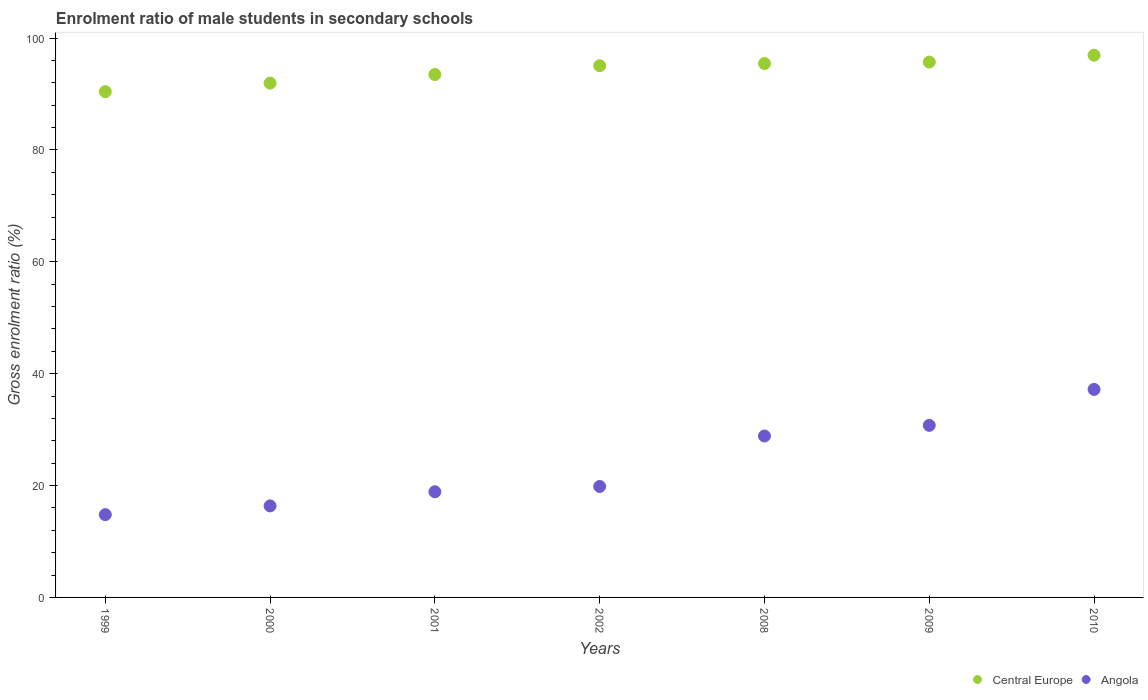How many different coloured dotlines are there?
Provide a succinct answer. 2. What is the enrolment ratio of male students in secondary schools in Angola in 2000?
Your response must be concise. 16.37. Across all years, what is the maximum enrolment ratio of male students in secondary schools in Angola?
Offer a very short reply. 37.19. Across all years, what is the minimum enrolment ratio of male students in secondary schools in Central Europe?
Provide a succinct answer. 90.43. In which year was the enrolment ratio of male students in secondary schools in Central Europe maximum?
Provide a succinct answer. 2010. In which year was the enrolment ratio of male students in secondary schools in Angola minimum?
Provide a short and direct response. 1999. What is the total enrolment ratio of male students in secondary schools in Central Europe in the graph?
Ensure brevity in your answer.  659.03. What is the difference between the enrolment ratio of male students in secondary schools in Angola in 2000 and that in 2008?
Your answer should be very brief. -12.5. What is the difference between the enrolment ratio of male students in secondary schools in Angola in 1999 and the enrolment ratio of male students in secondary schools in Central Europe in 2001?
Your response must be concise. -78.69. What is the average enrolment ratio of male students in secondary schools in Angola per year?
Your answer should be very brief. 23.82. In the year 2002, what is the difference between the enrolment ratio of male students in secondary schools in Central Europe and enrolment ratio of male students in secondary schools in Angola?
Keep it short and to the point. 75.22. What is the ratio of the enrolment ratio of male students in secondary schools in Angola in 2008 to that in 2010?
Your response must be concise. 0.78. Is the enrolment ratio of male students in secondary schools in Central Europe in 2000 less than that in 2001?
Your answer should be compact. Yes. What is the difference between the highest and the second highest enrolment ratio of male students in secondary schools in Angola?
Offer a very short reply. 6.42. What is the difference between the highest and the lowest enrolment ratio of male students in secondary schools in Angola?
Offer a very short reply. 22.39. In how many years, is the enrolment ratio of male students in secondary schools in Central Europe greater than the average enrolment ratio of male students in secondary schools in Central Europe taken over all years?
Offer a terse response. 4. Is the enrolment ratio of male students in secondary schools in Angola strictly less than the enrolment ratio of male students in secondary schools in Central Europe over the years?
Give a very brief answer. Yes. What is the difference between two consecutive major ticks on the Y-axis?
Your answer should be compact. 20. Are the values on the major ticks of Y-axis written in scientific E-notation?
Make the answer very short. No. Does the graph contain grids?
Offer a terse response. No. What is the title of the graph?
Ensure brevity in your answer.  Enrolment ratio of male students in secondary schools. What is the label or title of the Y-axis?
Your answer should be compact. Gross enrolment ratio (%). What is the Gross enrolment ratio (%) of Central Europe in 1999?
Your answer should be very brief. 90.43. What is the Gross enrolment ratio (%) of Angola in 1999?
Provide a short and direct response. 14.8. What is the Gross enrolment ratio (%) in Central Europe in 2000?
Make the answer very short. 91.95. What is the Gross enrolment ratio (%) in Angola in 2000?
Your answer should be compact. 16.37. What is the Gross enrolment ratio (%) in Central Europe in 2001?
Your answer should be very brief. 93.49. What is the Gross enrolment ratio (%) of Angola in 2001?
Give a very brief answer. 18.89. What is the Gross enrolment ratio (%) of Central Europe in 2002?
Make the answer very short. 95.06. What is the Gross enrolment ratio (%) of Angola in 2002?
Your answer should be compact. 19.84. What is the Gross enrolment ratio (%) of Central Europe in 2008?
Your response must be concise. 95.45. What is the Gross enrolment ratio (%) of Angola in 2008?
Offer a terse response. 28.86. What is the Gross enrolment ratio (%) in Central Europe in 2009?
Your answer should be very brief. 95.71. What is the Gross enrolment ratio (%) of Angola in 2009?
Your answer should be very brief. 30.77. What is the Gross enrolment ratio (%) of Central Europe in 2010?
Your answer should be compact. 96.94. What is the Gross enrolment ratio (%) of Angola in 2010?
Offer a very short reply. 37.19. Across all years, what is the maximum Gross enrolment ratio (%) of Central Europe?
Give a very brief answer. 96.94. Across all years, what is the maximum Gross enrolment ratio (%) of Angola?
Your answer should be very brief. 37.19. Across all years, what is the minimum Gross enrolment ratio (%) in Central Europe?
Your answer should be very brief. 90.43. Across all years, what is the minimum Gross enrolment ratio (%) of Angola?
Provide a short and direct response. 14.8. What is the total Gross enrolment ratio (%) of Central Europe in the graph?
Keep it short and to the point. 659.03. What is the total Gross enrolment ratio (%) of Angola in the graph?
Provide a succinct answer. 166.71. What is the difference between the Gross enrolment ratio (%) in Central Europe in 1999 and that in 2000?
Your answer should be very brief. -1.52. What is the difference between the Gross enrolment ratio (%) of Angola in 1999 and that in 2000?
Ensure brevity in your answer.  -1.57. What is the difference between the Gross enrolment ratio (%) of Central Europe in 1999 and that in 2001?
Your response must be concise. -3.06. What is the difference between the Gross enrolment ratio (%) in Angola in 1999 and that in 2001?
Your answer should be compact. -4.09. What is the difference between the Gross enrolment ratio (%) in Central Europe in 1999 and that in 2002?
Ensure brevity in your answer.  -4.63. What is the difference between the Gross enrolment ratio (%) of Angola in 1999 and that in 2002?
Provide a short and direct response. -5.04. What is the difference between the Gross enrolment ratio (%) in Central Europe in 1999 and that in 2008?
Give a very brief answer. -5.03. What is the difference between the Gross enrolment ratio (%) of Angola in 1999 and that in 2008?
Offer a very short reply. -14.06. What is the difference between the Gross enrolment ratio (%) of Central Europe in 1999 and that in 2009?
Your response must be concise. -5.29. What is the difference between the Gross enrolment ratio (%) of Angola in 1999 and that in 2009?
Give a very brief answer. -15.97. What is the difference between the Gross enrolment ratio (%) in Central Europe in 1999 and that in 2010?
Keep it short and to the point. -6.51. What is the difference between the Gross enrolment ratio (%) in Angola in 1999 and that in 2010?
Give a very brief answer. -22.39. What is the difference between the Gross enrolment ratio (%) in Central Europe in 2000 and that in 2001?
Offer a terse response. -1.53. What is the difference between the Gross enrolment ratio (%) in Angola in 2000 and that in 2001?
Offer a terse response. -2.52. What is the difference between the Gross enrolment ratio (%) of Central Europe in 2000 and that in 2002?
Make the answer very short. -3.11. What is the difference between the Gross enrolment ratio (%) of Angola in 2000 and that in 2002?
Offer a very short reply. -3.47. What is the difference between the Gross enrolment ratio (%) in Central Europe in 2000 and that in 2008?
Keep it short and to the point. -3.5. What is the difference between the Gross enrolment ratio (%) in Angola in 2000 and that in 2008?
Offer a terse response. -12.5. What is the difference between the Gross enrolment ratio (%) in Central Europe in 2000 and that in 2009?
Your response must be concise. -3.76. What is the difference between the Gross enrolment ratio (%) in Angola in 2000 and that in 2009?
Provide a short and direct response. -14.4. What is the difference between the Gross enrolment ratio (%) of Central Europe in 2000 and that in 2010?
Offer a terse response. -4.98. What is the difference between the Gross enrolment ratio (%) of Angola in 2000 and that in 2010?
Ensure brevity in your answer.  -20.82. What is the difference between the Gross enrolment ratio (%) of Central Europe in 2001 and that in 2002?
Offer a terse response. -1.57. What is the difference between the Gross enrolment ratio (%) in Angola in 2001 and that in 2002?
Your answer should be compact. -0.95. What is the difference between the Gross enrolment ratio (%) in Central Europe in 2001 and that in 2008?
Keep it short and to the point. -1.97. What is the difference between the Gross enrolment ratio (%) of Angola in 2001 and that in 2008?
Ensure brevity in your answer.  -9.97. What is the difference between the Gross enrolment ratio (%) in Central Europe in 2001 and that in 2009?
Ensure brevity in your answer.  -2.23. What is the difference between the Gross enrolment ratio (%) of Angola in 2001 and that in 2009?
Make the answer very short. -11.88. What is the difference between the Gross enrolment ratio (%) in Central Europe in 2001 and that in 2010?
Your answer should be compact. -3.45. What is the difference between the Gross enrolment ratio (%) of Angola in 2001 and that in 2010?
Your answer should be compact. -18.3. What is the difference between the Gross enrolment ratio (%) of Central Europe in 2002 and that in 2008?
Make the answer very short. -0.39. What is the difference between the Gross enrolment ratio (%) of Angola in 2002 and that in 2008?
Your answer should be very brief. -9.02. What is the difference between the Gross enrolment ratio (%) in Central Europe in 2002 and that in 2009?
Offer a very short reply. -0.65. What is the difference between the Gross enrolment ratio (%) of Angola in 2002 and that in 2009?
Keep it short and to the point. -10.93. What is the difference between the Gross enrolment ratio (%) of Central Europe in 2002 and that in 2010?
Make the answer very short. -1.88. What is the difference between the Gross enrolment ratio (%) in Angola in 2002 and that in 2010?
Make the answer very short. -17.35. What is the difference between the Gross enrolment ratio (%) of Central Europe in 2008 and that in 2009?
Give a very brief answer. -0.26. What is the difference between the Gross enrolment ratio (%) in Angola in 2008 and that in 2009?
Give a very brief answer. -1.9. What is the difference between the Gross enrolment ratio (%) of Central Europe in 2008 and that in 2010?
Offer a very short reply. -1.48. What is the difference between the Gross enrolment ratio (%) of Angola in 2008 and that in 2010?
Ensure brevity in your answer.  -8.33. What is the difference between the Gross enrolment ratio (%) in Central Europe in 2009 and that in 2010?
Your answer should be very brief. -1.22. What is the difference between the Gross enrolment ratio (%) of Angola in 2009 and that in 2010?
Ensure brevity in your answer.  -6.42. What is the difference between the Gross enrolment ratio (%) of Central Europe in 1999 and the Gross enrolment ratio (%) of Angola in 2000?
Offer a very short reply. 74.06. What is the difference between the Gross enrolment ratio (%) of Central Europe in 1999 and the Gross enrolment ratio (%) of Angola in 2001?
Your answer should be compact. 71.54. What is the difference between the Gross enrolment ratio (%) of Central Europe in 1999 and the Gross enrolment ratio (%) of Angola in 2002?
Provide a short and direct response. 70.59. What is the difference between the Gross enrolment ratio (%) of Central Europe in 1999 and the Gross enrolment ratio (%) of Angola in 2008?
Make the answer very short. 61.57. What is the difference between the Gross enrolment ratio (%) of Central Europe in 1999 and the Gross enrolment ratio (%) of Angola in 2009?
Your answer should be compact. 59.66. What is the difference between the Gross enrolment ratio (%) in Central Europe in 1999 and the Gross enrolment ratio (%) in Angola in 2010?
Your answer should be very brief. 53.24. What is the difference between the Gross enrolment ratio (%) of Central Europe in 2000 and the Gross enrolment ratio (%) of Angola in 2001?
Your answer should be compact. 73.06. What is the difference between the Gross enrolment ratio (%) of Central Europe in 2000 and the Gross enrolment ratio (%) of Angola in 2002?
Provide a short and direct response. 72.12. What is the difference between the Gross enrolment ratio (%) in Central Europe in 2000 and the Gross enrolment ratio (%) in Angola in 2008?
Your answer should be compact. 63.09. What is the difference between the Gross enrolment ratio (%) of Central Europe in 2000 and the Gross enrolment ratio (%) of Angola in 2009?
Your response must be concise. 61.19. What is the difference between the Gross enrolment ratio (%) of Central Europe in 2000 and the Gross enrolment ratio (%) of Angola in 2010?
Provide a succinct answer. 54.76. What is the difference between the Gross enrolment ratio (%) of Central Europe in 2001 and the Gross enrolment ratio (%) of Angola in 2002?
Provide a short and direct response. 73.65. What is the difference between the Gross enrolment ratio (%) of Central Europe in 2001 and the Gross enrolment ratio (%) of Angola in 2008?
Ensure brevity in your answer.  64.63. What is the difference between the Gross enrolment ratio (%) of Central Europe in 2001 and the Gross enrolment ratio (%) of Angola in 2009?
Make the answer very short. 62.72. What is the difference between the Gross enrolment ratio (%) of Central Europe in 2001 and the Gross enrolment ratio (%) of Angola in 2010?
Your response must be concise. 56.3. What is the difference between the Gross enrolment ratio (%) of Central Europe in 2002 and the Gross enrolment ratio (%) of Angola in 2008?
Keep it short and to the point. 66.2. What is the difference between the Gross enrolment ratio (%) of Central Europe in 2002 and the Gross enrolment ratio (%) of Angola in 2009?
Provide a short and direct response. 64.29. What is the difference between the Gross enrolment ratio (%) of Central Europe in 2002 and the Gross enrolment ratio (%) of Angola in 2010?
Offer a terse response. 57.87. What is the difference between the Gross enrolment ratio (%) in Central Europe in 2008 and the Gross enrolment ratio (%) in Angola in 2009?
Offer a terse response. 64.69. What is the difference between the Gross enrolment ratio (%) in Central Europe in 2008 and the Gross enrolment ratio (%) in Angola in 2010?
Give a very brief answer. 58.26. What is the difference between the Gross enrolment ratio (%) of Central Europe in 2009 and the Gross enrolment ratio (%) of Angola in 2010?
Keep it short and to the point. 58.52. What is the average Gross enrolment ratio (%) of Central Europe per year?
Keep it short and to the point. 94.15. What is the average Gross enrolment ratio (%) of Angola per year?
Make the answer very short. 23.82. In the year 1999, what is the difference between the Gross enrolment ratio (%) of Central Europe and Gross enrolment ratio (%) of Angola?
Provide a short and direct response. 75.63. In the year 2000, what is the difference between the Gross enrolment ratio (%) of Central Europe and Gross enrolment ratio (%) of Angola?
Your answer should be compact. 75.59. In the year 2001, what is the difference between the Gross enrolment ratio (%) in Central Europe and Gross enrolment ratio (%) in Angola?
Your response must be concise. 74.6. In the year 2002, what is the difference between the Gross enrolment ratio (%) of Central Europe and Gross enrolment ratio (%) of Angola?
Keep it short and to the point. 75.22. In the year 2008, what is the difference between the Gross enrolment ratio (%) of Central Europe and Gross enrolment ratio (%) of Angola?
Keep it short and to the point. 66.59. In the year 2009, what is the difference between the Gross enrolment ratio (%) in Central Europe and Gross enrolment ratio (%) in Angola?
Make the answer very short. 64.95. In the year 2010, what is the difference between the Gross enrolment ratio (%) in Central Europe and Gross enrolment ratio (%) in Angola?
Give a very brief answer. 59.75. What is the ratio of the Gross enrolment ratio (%) in Central Europe in 1999 to that in 2000?
Give a very brief answer. 0.98. What is the ratio of the Gross enrolment ratio (%) of Angola in 1999 to that in 2000?
Offer a very short reply. 0.9. What is the ratio of the Gross enrolment ratio (%) of Central Europe in 1999 to that in 2001?
Give a very brief answer. 0.97. What is the ratio of the Gross enrolment ratio (%) in Angola in 1999 to that in 2001?
Your answer should be compact. 0.78. What is the ratio of the Gross enrolment ratio (%) in Central Europe in 1999 to that in 2002?
Keep it short and to the point. 0.95. What is the ratio of the Gross enrolment ratio (%) in Angola in 1999 to that in 2002?
Provide a succinct answer. 0.75. What is the ratio of the Gross enrolment ratio (%) of Central Europe in 1999 to that in 2008?
Your response must be concise. 0.95. What is the ratio of the Gross enrolment ratio (%) in Angola in 1999 to that in 2008?
Give a very brief answer. 0.51. What is the ratio of the Gross enrolment ratio (%) of Central Europe in 1999 to that in 2009?
Keep it short and to the point. 0.94. What is the ratio of the Gross enrolment ratio (%) in Angola in 1999 to that in 2009?
Ensure brevity in your answer.  0.48. What is the ratio of the Gross enrolment ratio (%) of Central Europe in 1999 to that in 2010?
Give a very brief answer. 0.93. What is the ratio of the Gross enrolment ratio (%) in Angola in 1999 to that in 2010?
Provide a short and direct response. 0.4. What is the ratio of the Gross enrolment ratio (%) in Central Europe in 2000 to that in 2001?
Provide a succinct answer. 0.98. What is the ratio of the Gross enrolment ratio (%) of Angola in 2000 to that in 2001?
Your answer should be very brief. 0.87. What is the ratio of the Gross enrolment ratio (%) in Central Europe in 2000 to that in 2002?
Your answer should be compact. 0.97. What is the ratio of the Gross enrolment ratio (%) in Angola in 2000 to that in 2002?
Ensure brevity in your answer.  0.82. What is the ratio of the Gross enrolment ratio (%) of Central Europe in 2000 to that in 2008?
Your answer should be very brief. 0.96. What is the ratio of the Gross enrolment ratio (%) of Angola in 2000 to that in 2008?
Give a very brief answer. 0.57. What is the ratio of the Gross enrolment ratio (%) in Central Europe in 2000 to that in 2009?
Keep it short and to the point. 0.96. What is the ratio of the Gross enrolment ratio (%) in Angola in 2000 to that in 2009?
Make the answer very short. 0.53. What is the ratio of the Gross enrolment ratio (%) in Central Europe in 2000 to that in 2010?
Offer a very short reply. 0.95. What is the ratio of the Gross enrolment ratio (%) in Angola in 2000 to that in 2010?
Offer a terse response. 0.44. What is the ratio of the Gross enrolment ratio (%) in Central Europe in 2001 to that in 2002?
Your answer should be compact. 0.98. What is the ratio of the Gross enrolment ratio (%) in Angola in 2001 to that in 2002?
Offer a terse response. 0.95. What is the ratio of the Gross enrolment ratio (%) in Central Europe in 2001 to that in 2008?
Provide a succinct answer. 0.98. What is the ratio of the Gross enrolment ratio (%) in Angola in 2001 to that in 2008?
Keep it short and to the point. 0.65. What is the ratio of the Gross enrolment ratio (%) of Central Europe in 2001 to that in 2009?
Offer a very short reply. 0.98. What is the ratio of the Gross enrolment ratio (%) in Angola in 2001 to that in 2009?
Keep it short and to the point. 0.61. What is the ratio of the Gross enrolment ratio (%) in Central Europe in 2001 to that in 2010?
Give a very brief answer. 0.96. What is the ratio of the Gross enrolment ratio (%) in Angola in 2001 to that in 2010?
Keep it short and to the point. 0.51. What is the ratio of the Gross enrolment ratio (%) in Angola in 2002 to that in 2008?
Your response must be concise. 0.69. What is the ratio of the Gross enrolment ratio (%) in Central Europe in 2002 to that in 2009?
Offer a very short reply. 0.99. What is the ratio of the Gross enrolment ratio (%) in Angola in 2002 to that in 2009?
Offer a very short reply. 0.64. What is the ratio of the Gross enrolment ratio (%) in Central Europe in 2002 to that in 2010?
Ensure brevity in your answer.  0.98. What is the ratio of the Gross enrolment ratio (%) of Angola in 2002 to that in 2010?
Your answer should be very brief. 0.53. What is the ratio of the Gross enrolment ratio (%) in Central Europe in 2008 to that in 2009?
Keep it short and to the point. 1. What is the ratio of the Gross enrolment ratio (%) in Angola in 2008 to that in 2009?
Your answer should be compact. 0.94. What is the ratio of the Gross enrolment ratio (%) in Central Europe in 2008 to that in 2010?
Keep it short and to the point. 0.98. What is the ratio of the Gross enrolment ratio (%) in Angola in 2008 to that in 2010?
Your answer should be very brief. 0.78. What is the ratio of the Gross enrolment ratio (%) of Central Europe in 2009 to that in 2010?
Offer a very short reply. 0.99. What is the ratio of the Gross enrolment ratio (%) of Angola in 2009 to that in 2010?
Offer a very short reply. 0.83. What is the difference between the highest and the second highest Gross enrolment ratio (%) in Central Europe?
Your answer should be compact. 1.22. What is the difference between the highest and the second highest Gross enrolment ratio (%) of Angola?
Your response must be concise. 6.42. What is the difference between the highest and the lowest Gross enrolment ratio (%) in Central Europe?
Provide a short and direct response. 6.51. What is the difference between the highest and the lowest Gross enrolment ratio (%) in Angola?
Keep it short and to the point. 22.39. 